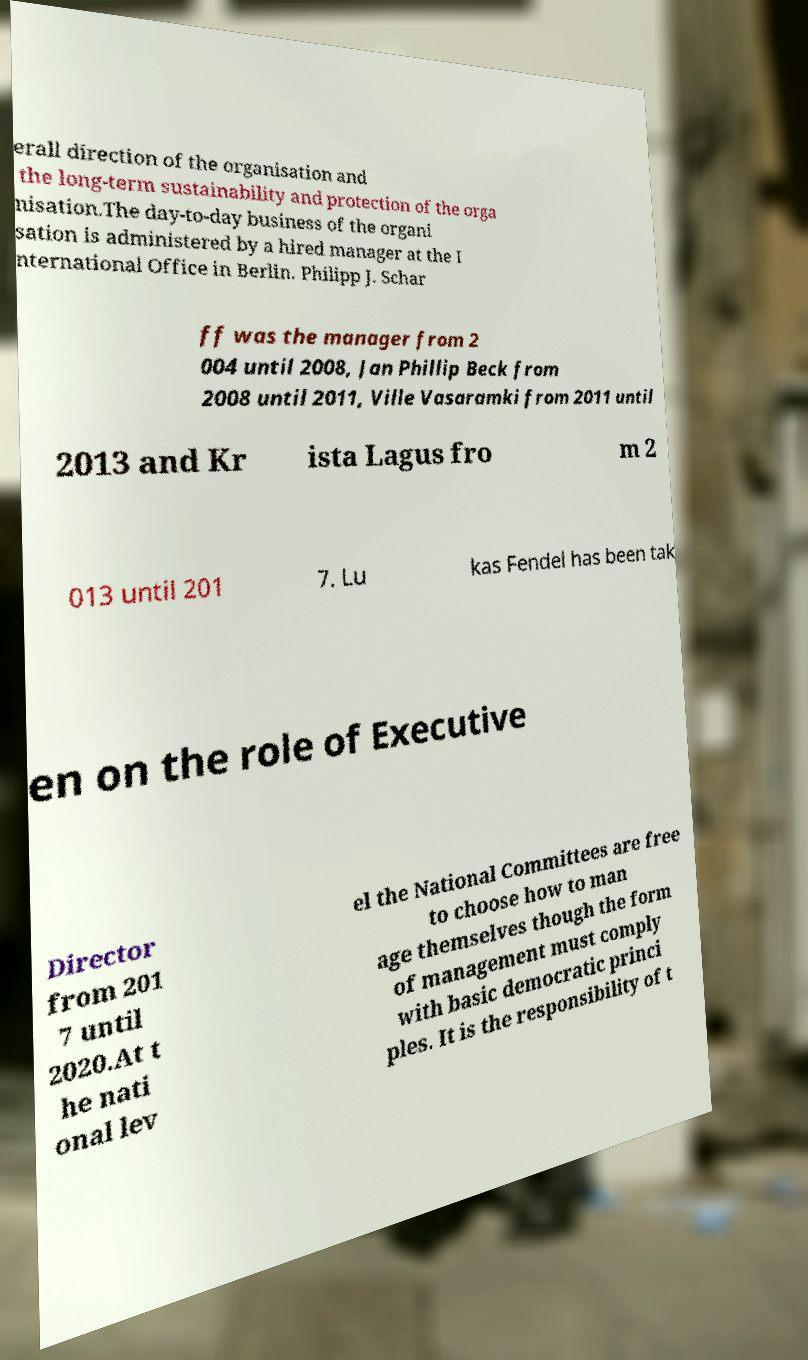Can you read and provide the text displayed in the image?This photo seems to have some interesting text. Can you extract and type it out for me? erall direction of the organisation and the long-term sustainability and protection of the orga nisation.The day-to-day business of the organi sation is administered by a hired manager at the I nternational Office in Berlin. Philipp J. Schar ff was the manager from 2 004 until 2008, Jan Phillip Beck from 2008 until 2011, Ville Vasaramki from 2011 until 2013 and Kr ista Lagus fro m 2 013 until 201 7. Lu kas Fendel has been tak en on the role of Executive Director from 201 7 until 2020.At t he nati onal lev el the National Committees are free to choose how to man age themselves though the form of management must comply with basic democratic princi ples. It is the responsibility of t 